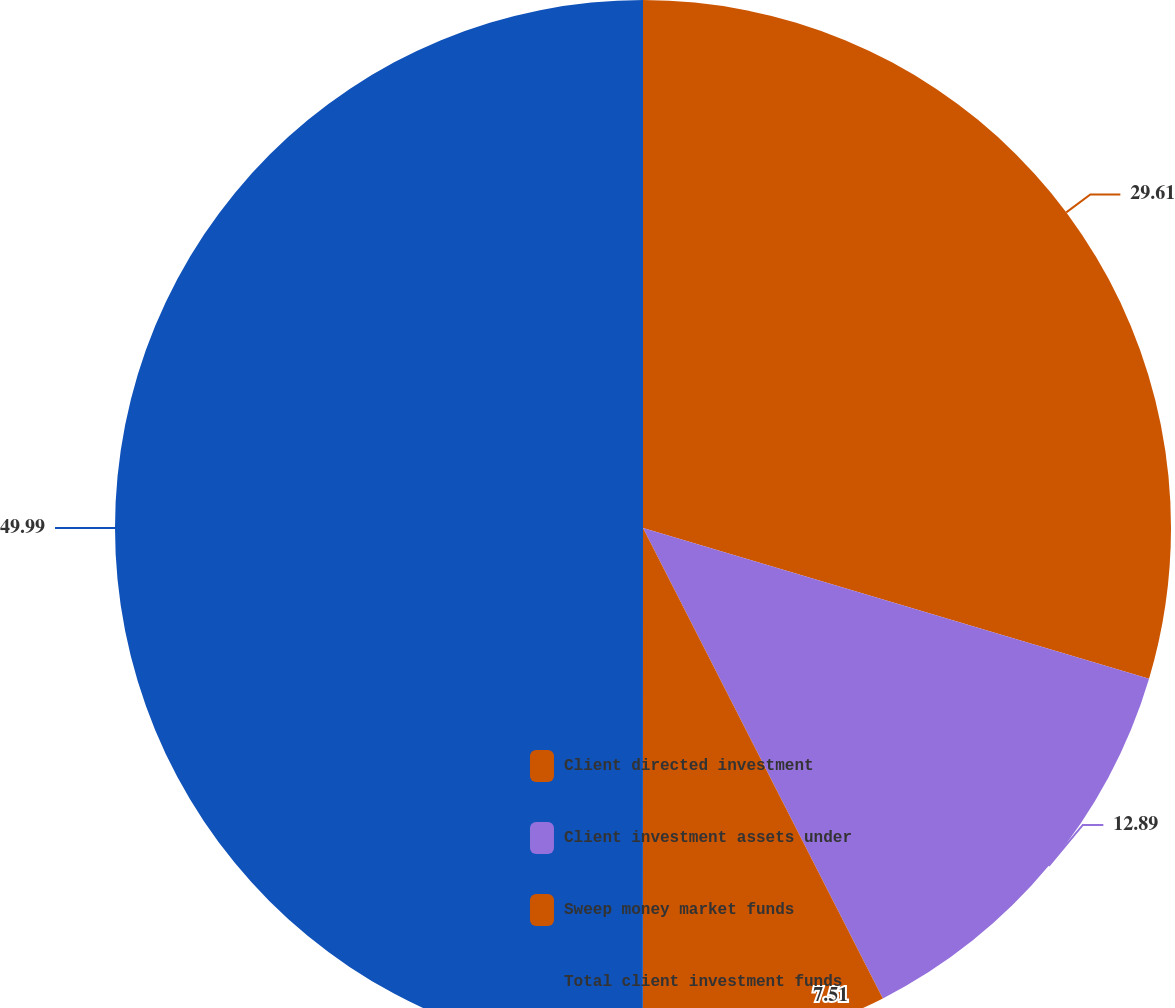<chart> <loc_0><loc_0><loc_500><loc_500><pie_chart><fcel>Client directed investment<fcel>Client investment assets under<fcel>Sweep money market funds<fcel>Total client investment funds<nl><fcel>29.61%<fcel>12.89%<fcel>7.51%<fcel>50.0%<nl></chart> 